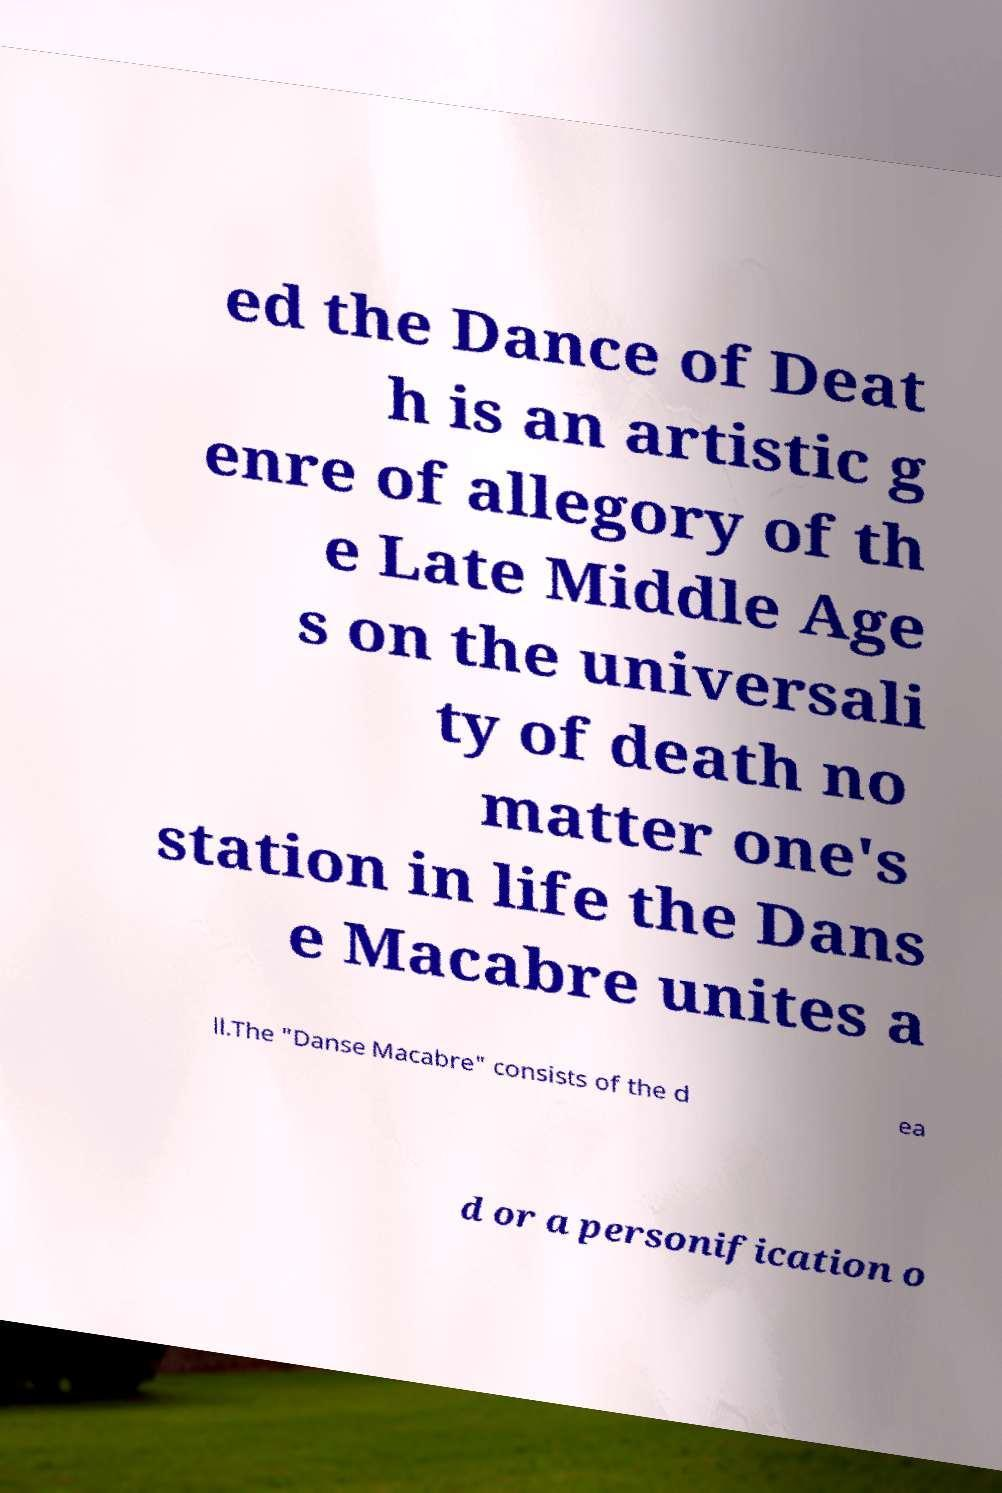Could you extract and type out the text from this image? ed the Dance of Deat h is an artistic g enre of allegory of th e Late Middle Age s on the universali ty of death no matter one's station in life the Dans e Macabre unites a ll.The "Danse Macabre" consists of the d ea d or a personification o 